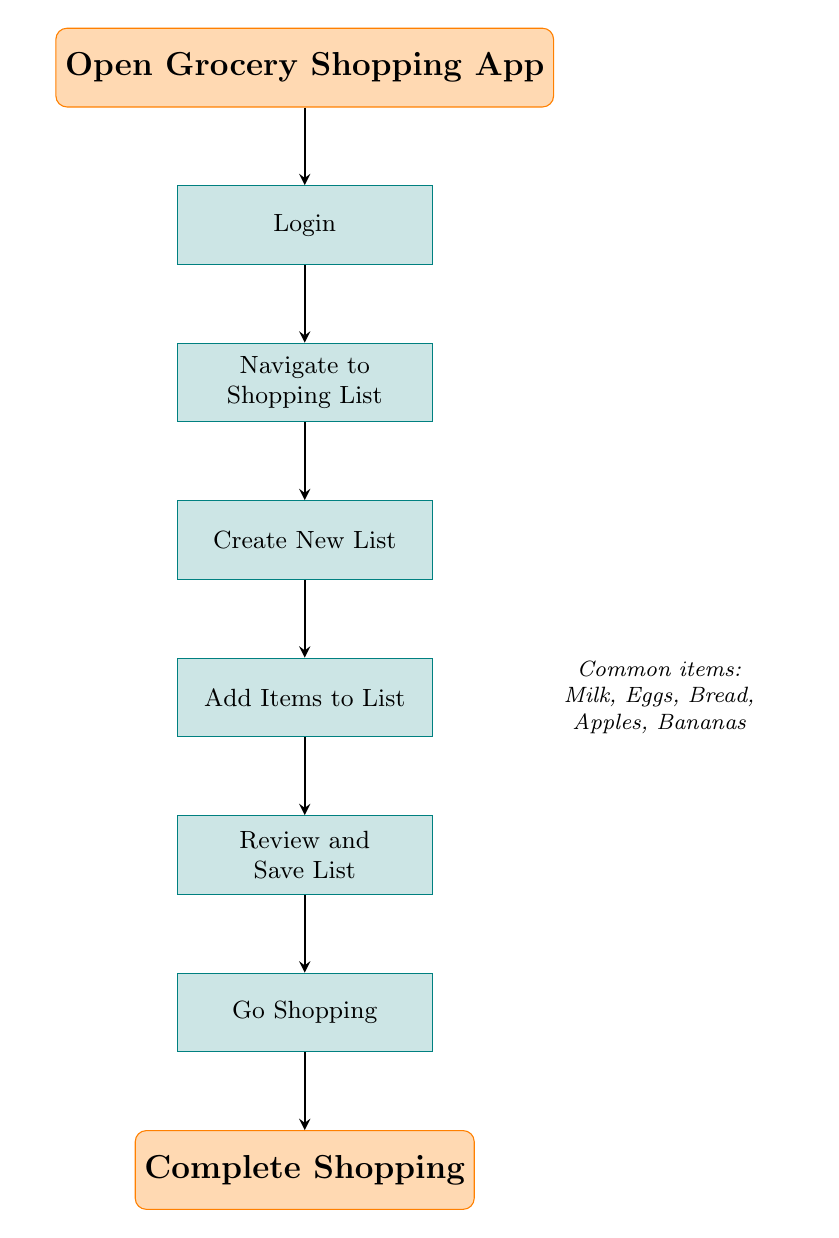What is the first action in the flow chart? The first action in the flow chart is represented by the first node, which is "Open Grocery Shopping App." This node initiates the entire grocery shopping process.
Answer: Open Grocery Shopping App How many steps are there in the process? By counting the steps listed in the flow chart from "Login" to "Go Shopping," we find there are a total of six steps, each of which corresponds to an action in the grocery shopping list creation process.
Answer: 6 What is the last action before completing shopping? The last action before completing shopping is indicated by the node before "Complete Shopping," which is "Go Shopping." This action involves taking the created list to the grocery store.
Answer: Go Shopping What item is commonly added to the shopping list? A common item that is specifically mentioned in the flow chart is "Milk," which is listed among other common grocery items after the node "Add Items to List."
Answer: Milk What action follows logging in? The action that follows logging in is "Navigate to Shopping List." After entering the username and password, the next step in the diagram is to tap on the 'Shopping List' icon.
Answer: Navigate to Shopping List Which node includes a note about common items? The node that includes a note about common items is "Add Items to List." This node provides additional information on common items that can be added to the list, such as Milk, Eggs, Bread, Apples, and Bananas.
Answer: Add Items to List 